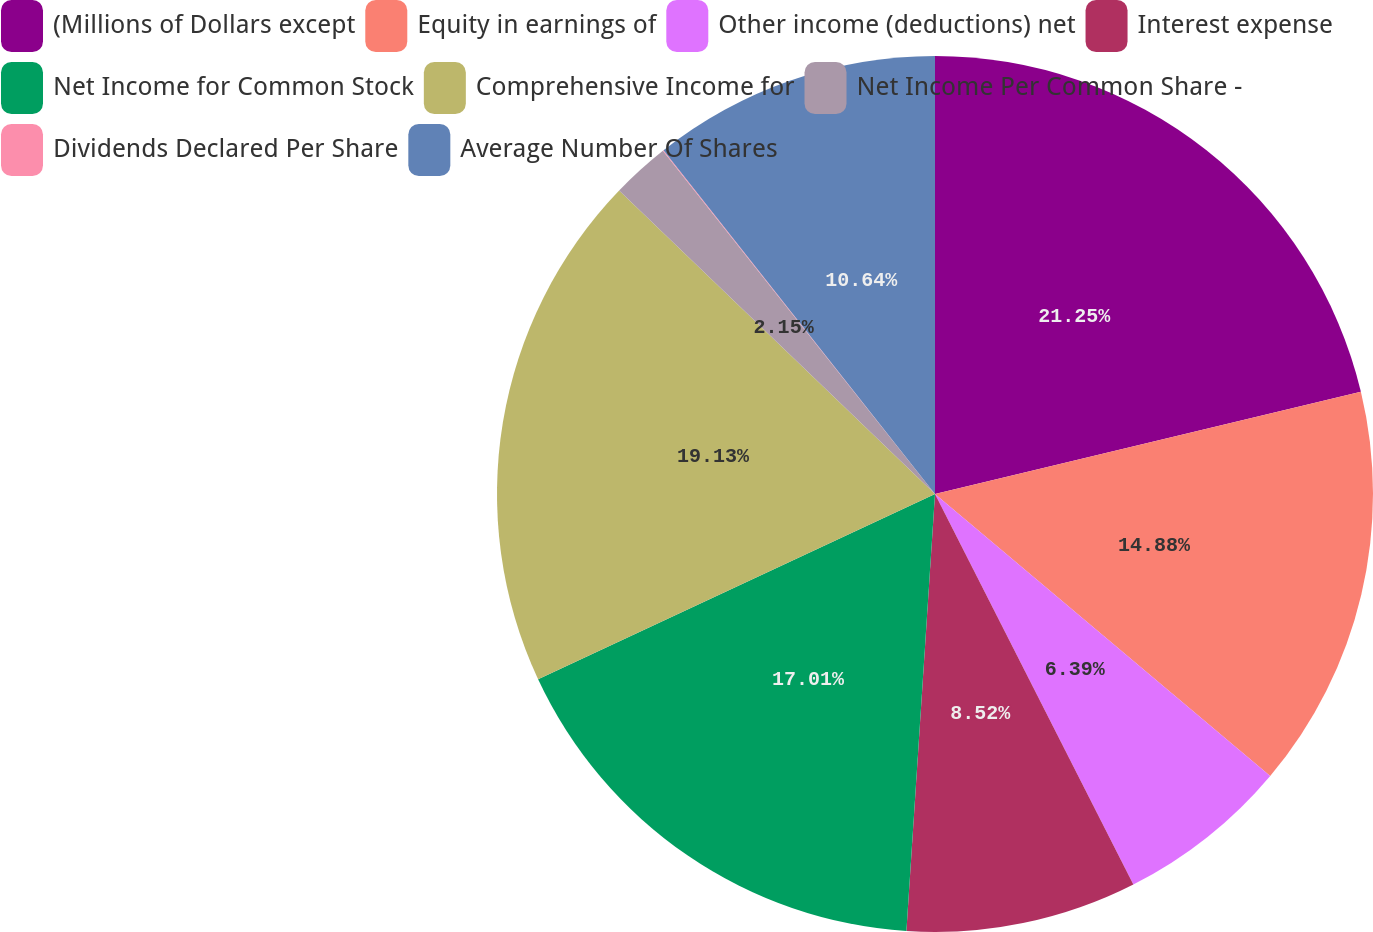<chart> <loc_0><loc_0><loc_500><loc_500><pie_chart><fcel>(Millions of Dollars except<fcel>Equity in earnings of<fcel>Other income (deductions) net<fcel>Interest expense<fcel>Net Income for Common Stock<fcel>Comprehensive Income for<fcel>Net Income Per Common Share -<fcel>Dividends Declared Per Share<fcel>Average Number Of Shares<nl><fcel>21.25%<fcel>14.88%<fcel>6.39%<fcel>8.52%<fcel>17.01%<fcel>19.13%<fcel>2.15%<fcel>0.03%<fcel>10.64%<nl></chart> 